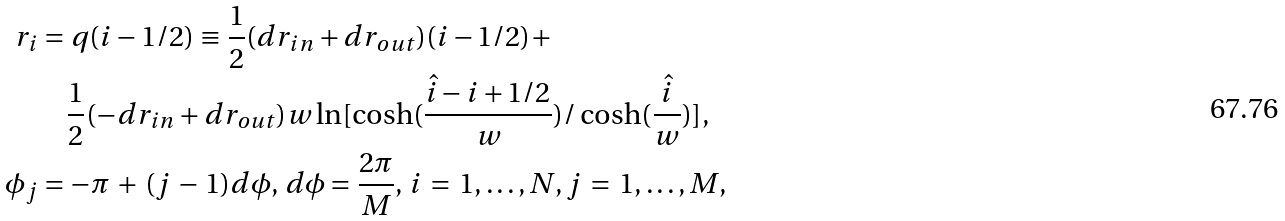Convert formula to latex. <formula><loc_0><loc_0><loc_500><loc_500>r _ { i } & = q ( i - 1 / 2 ) \equiv \frac { 1 } { 2 } ( d r _ { i n } + d r _ { o u t } ) ( i - 1 / 2 ) + \\ & \quad \frac { 1 } { 2 } ( - d r _ { i n } + d r _ { o u t } ) w \ln [ \cosh ( \frac { \hat { i } - i + 1 / 2 } { w } ) / \cosh ( \frac { \hat { i } } { w } ) ] , \\ \phi _ { j } & = - \pi \, + \, ( j \, - \, 1 ) d \phi , \, d \phi = \frac { 2 \pi } { M } , \, i \, = \, 1 , \dots , N , j \, = \, 1 , \dots , M ,</formula> 